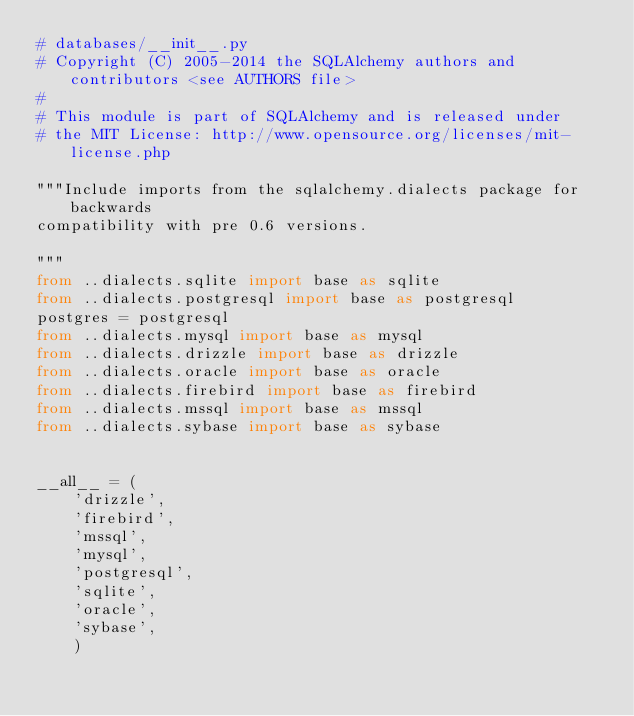Convert code to text. <code><loc_0><loc_0><loc_500><loc_500><_Python_># databases/__init__.py
# Copyright (C) 2005-2014 the SQLAlchemy authors and contributors <see AUTHORS file>
#
# This module is part of SQLAlchemy and is released under
# the MIT License: http://www.opensource.org/licenses/mit-license.php

"""Include imports from the sqlalchemy.dialects package for backwards
compatibility with pre 0.6 versions.

"""
from ..dialects.sqlite import base as sqlite
from ..dialects.postgresql import base as postgresql
postgres = postgresql
from ..dialects.mysql import base as mysql
from ..dialects.drizzle import base as drizzle
from ..dialects.oracle import base as oracle
from ..dialects.firebird import base as firebird
from ..dialects.mssql import base as mssql
from ..dialects.sybase import base as sybase


__all__ = (
    'drizzle',
    'firebird',
    'mssql',
    'mysql',
    'postgresql',
    'sqlite',
    'oracle',
    'sybase',
    )
</code> 